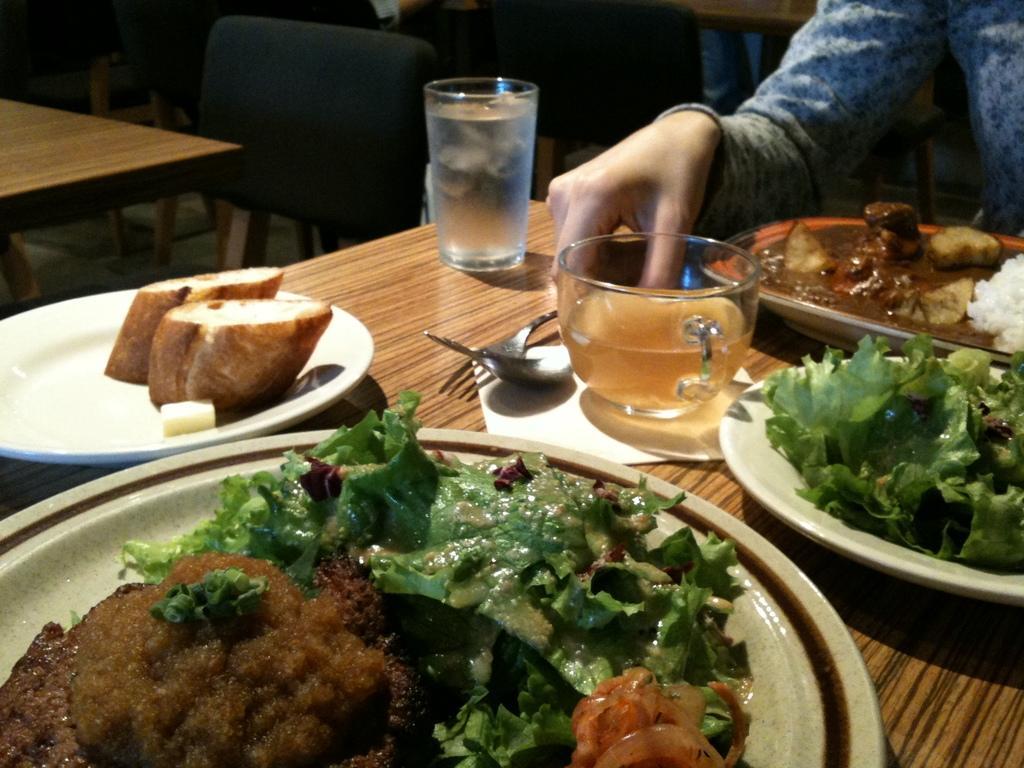Please provide a concise description of this image. In this image there is a person sitting behind the table. There is a food, plate, fork, spoon, glass, cup, tissue on the table. 